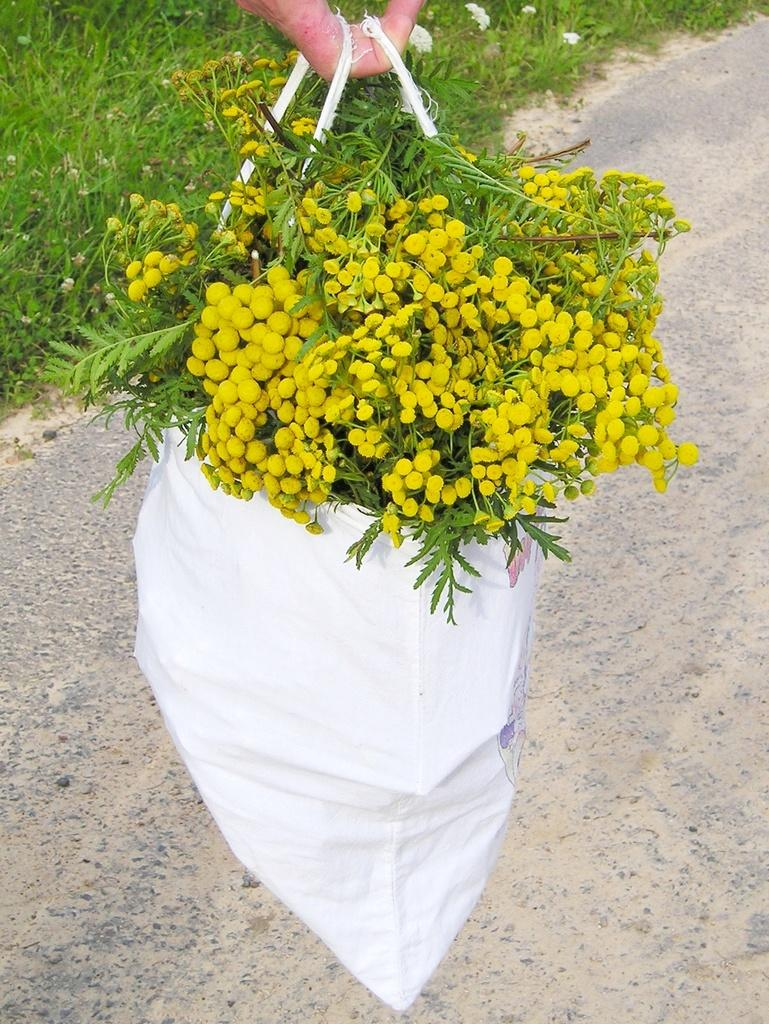What is the human finger holding in the image? The human finger is holding a carry bag in the image. What is inside the carry bag? The carry bag is filled with flowers, leaves, and stems. What can be seen in the background of the image? There is a road and grass in the background of the image. How many clocks are visible on the dress in the image? There is no dress or clocks present in the image. What type of airport can be seen in the background of the image? There is no airport visible in the image; it features a road and grass in the background. 